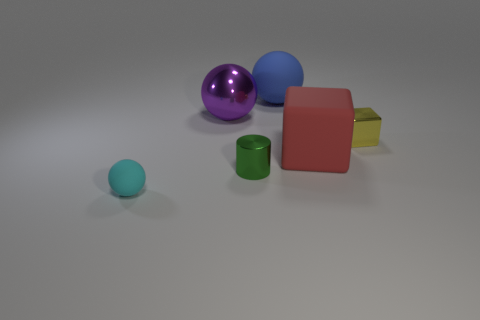Subtract all red spheres. Subtract all gray cylinders. How many spheres are left? 3 Add 2 big yellow matte balls. How many objects exist? 8 Subtract all cubes. How many objects are left? 4 Add 2 big green shiny objects. How many big green shiny objects exist? 2 Subtract 1 blue spheres. How many objects are left? 5 Subtract all gray rubber things. Subtract all large matte blocks. How many objects are left? 5 Add 5 cyan rubber balls. How many cyan rubber balls are left? 6 